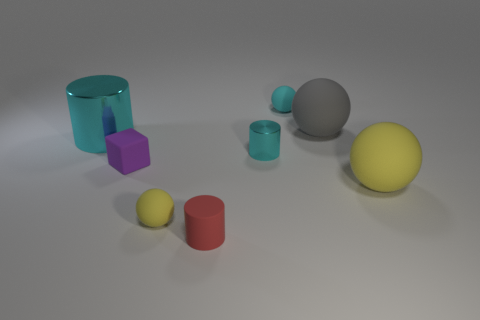There is a big rubber sphere behind the tiny cyan metal cylinder; is there a tiny yellow thing that is to the right of it?
Provide a short and direct response. No. The cylinder that is made of the same material as the big gray thing is what color?
Give a very brief answer. Red. Is the number of red shiny things greater than the number of tiny blocks?
Your response must be concise. No. How many things are either big objects that are right of the small rubber cylinder or purple blocks?
Your response must be concise. 3. Are there any matte cylinders that have the same size as the cube?
Your response must be concise. Yes. Is the number of matte blocks less than the number of yellow balls?
Ensure brevity in your answer.  Yes. How many spheres are either yellow rubber objects or tiny purple objects?
Your answer should be compact. 2. How many other small rubber cubes have the same color as the tiny cube?
Offer a very short reply. 0. There is a cylinder that is behind the small purple object and in front of the large shiny thing; what size is it?
Make the answer very short. Small. Is the number of tiny matte cylinders that are to the right of the large cyan object less than the number of gray matte cylinders?
Provide a succinct answer. No. 